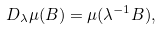<formula> <loc_0><loc_0><loc_500><loc_500>D _ { \lambda } \mu ( B ) = \mu ( \lambda ^ { - 1 } B ) ,</formula> 